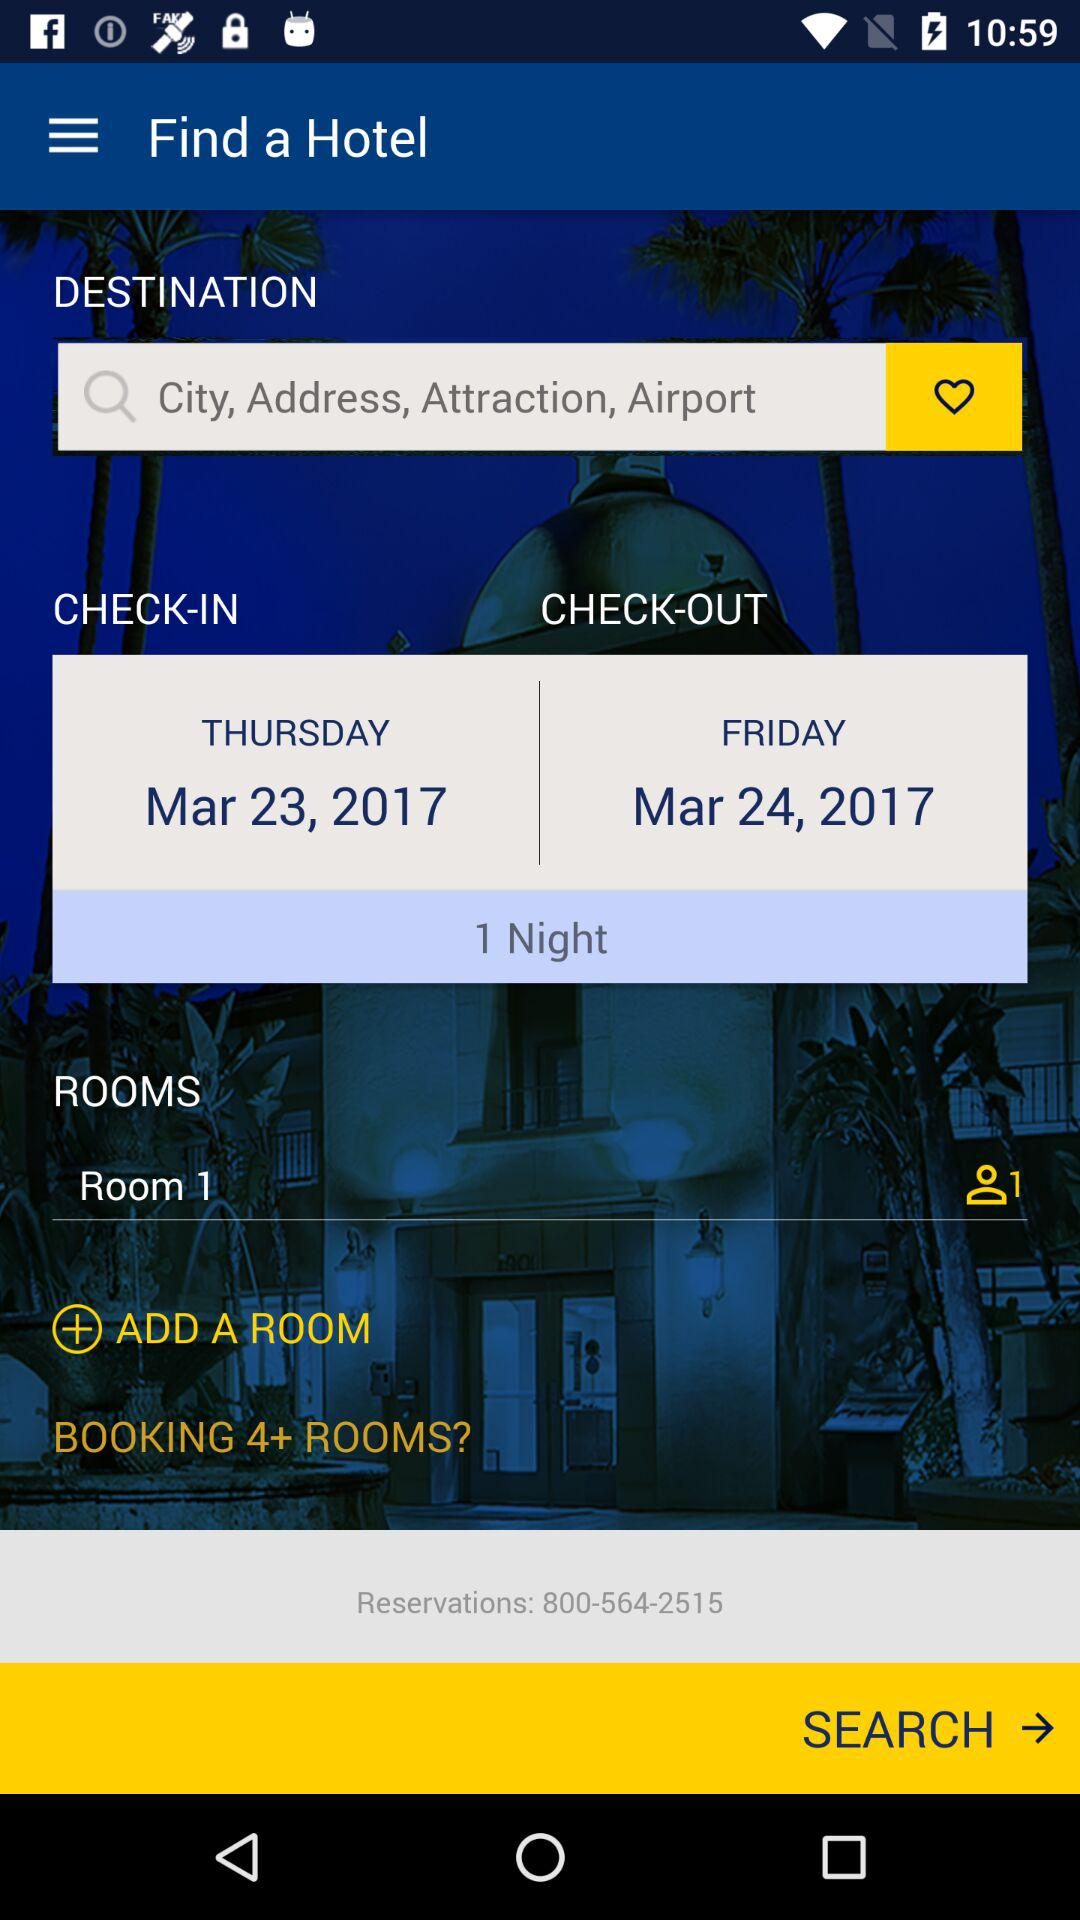How many rooms are currently selected?
Answer the question using a single word or phrase. 1 